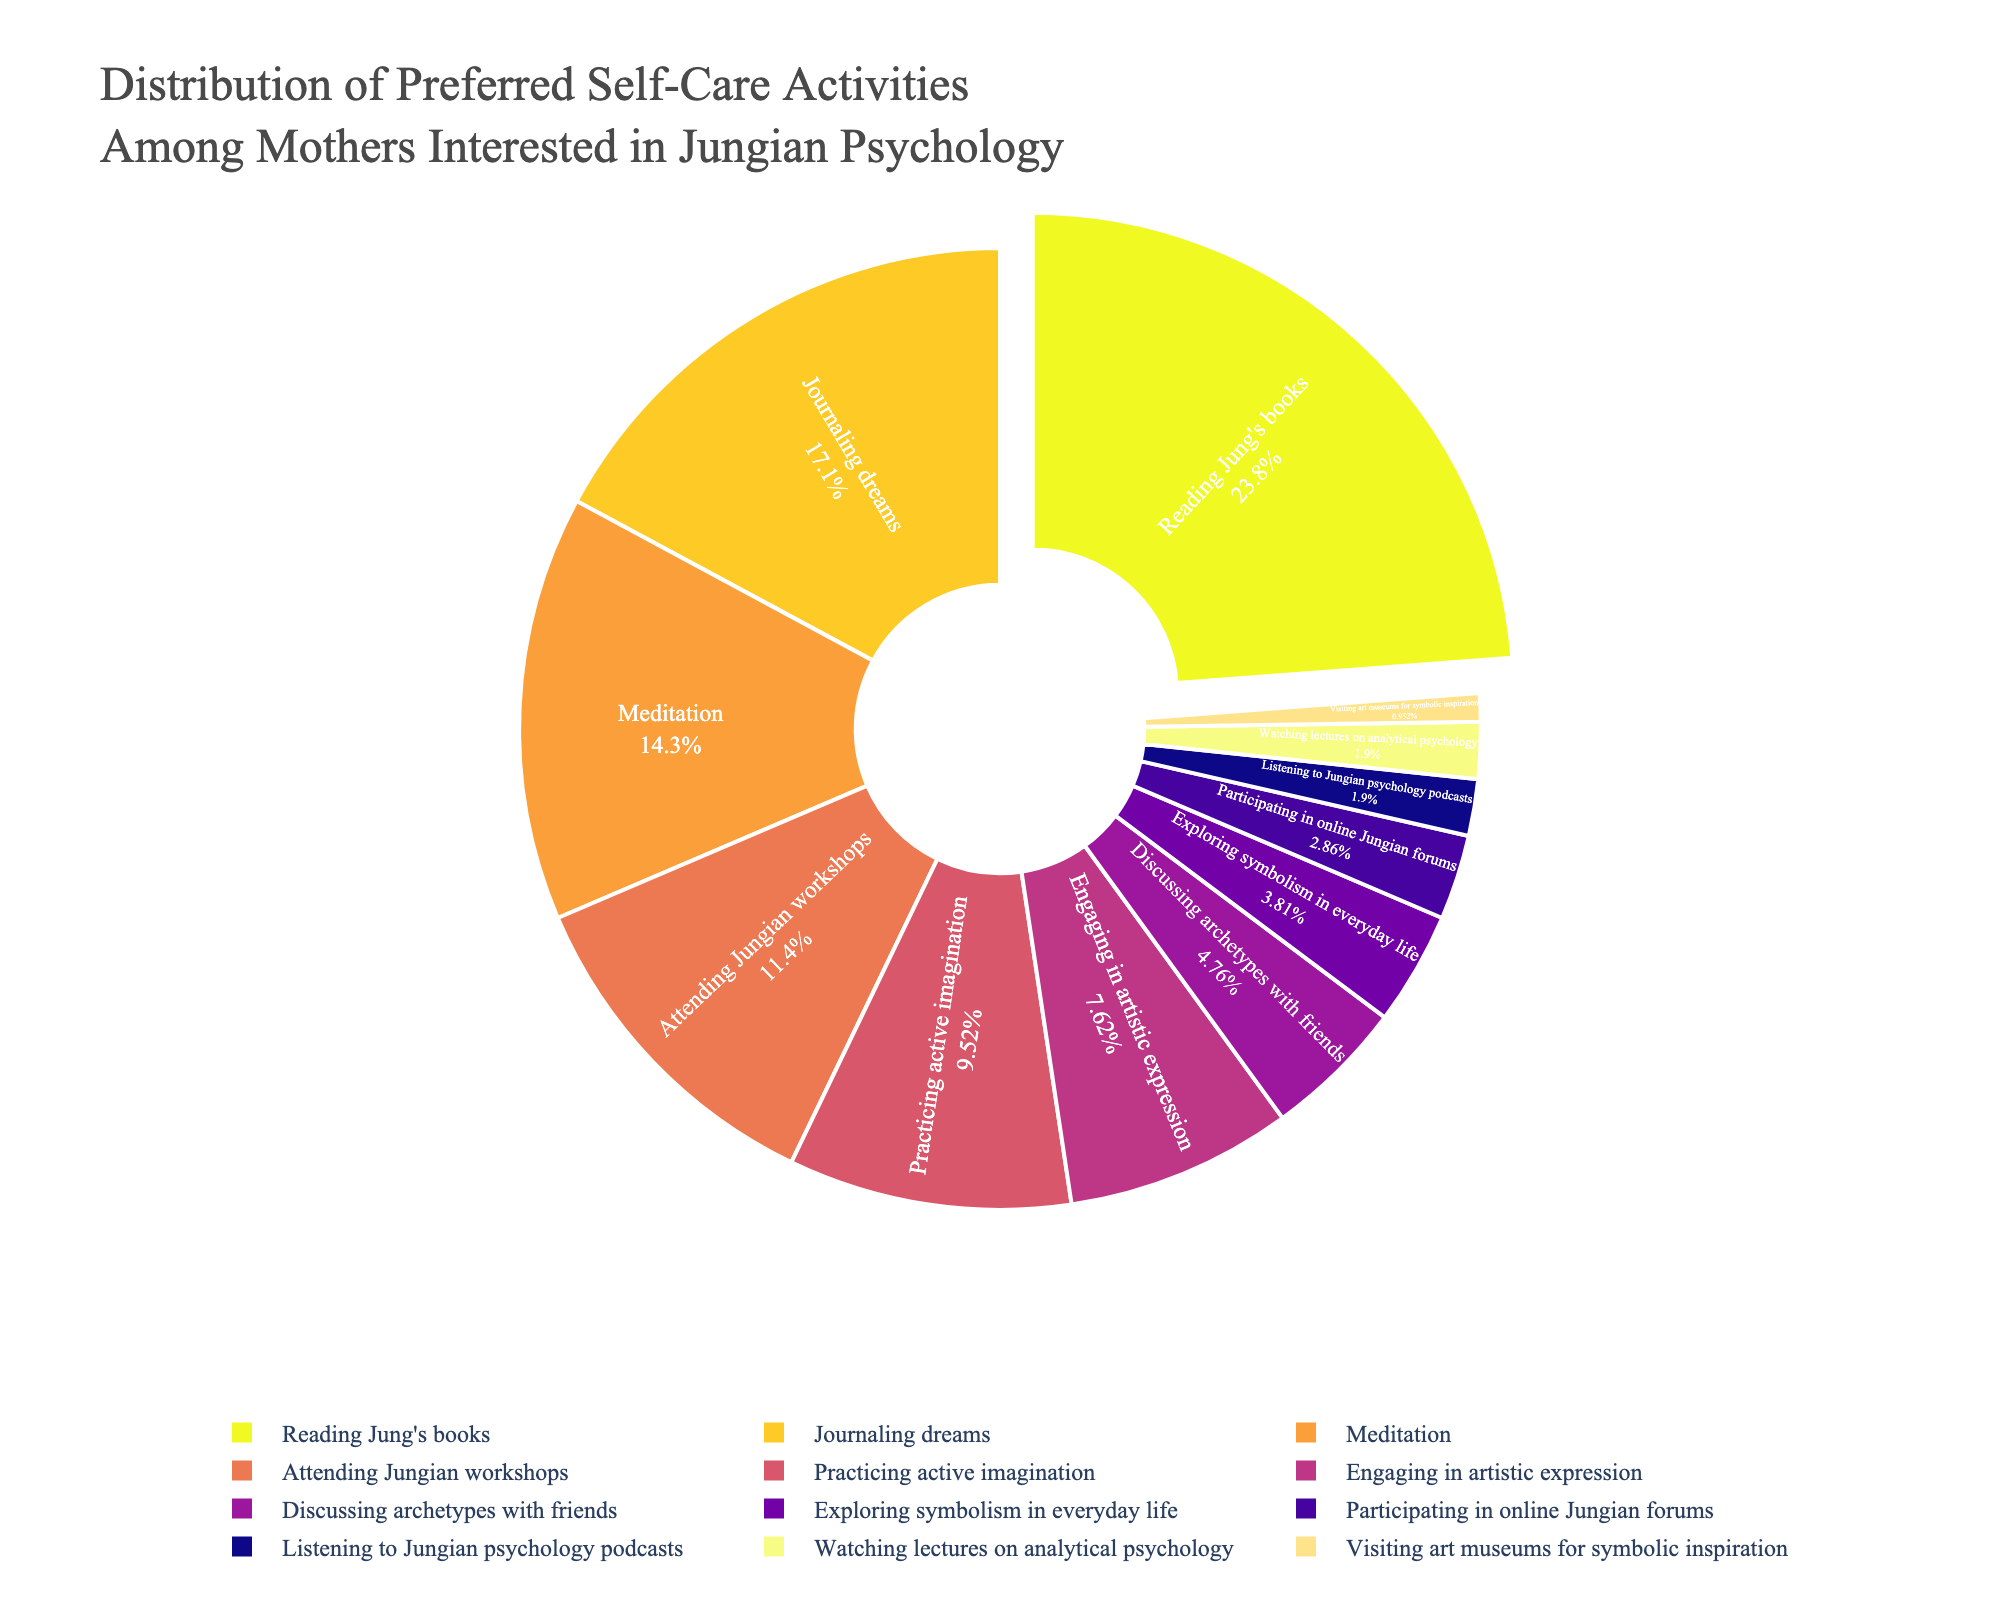Which activity has the highest percentage? The activity with the highest percentage corresponds to the largest slice in the pie chart. Observing the chart, the largest slice is for "Reading Jung's books".
Answer: Reading Jung's books What is the total percentage of activities related to writing (Reading Jung's books, Journaling dreams)? Sum the percentages of "Reading Jung's books" (25%) and "Journaling dreams" (18%) together.
Answer: 43% How many activities have a percentage lower than 10%? Count the slices in the pie chart that have percentages lower than 10%. "Practicing active imagination", "Engaging in artistic expression", "Discussing archetypes with friends", "Exploring symbolism in everyday life", "Participating in online Jungian forums", "Listening to Jungian psychology podcasts", "Watching lectures on analytical psychology", and "Visiting art museums for symbolic inspiration" all fall below 10%.
Answer: 8 Which activity has the smallest percentage? The activity with the smallest slice in the pie chart has the smallest percentage. The smallest slice corresponds to "Visiting art museums for symbolic inspiration".
Answer: Visiting art museums for symbolic inspiration What is the difference in percentage between the highest and lowest activities? Calculate the percentage difference between "Reading Jung's books" (25%) and "Visiting art museums for symbolic inspiration" (1%). Subtract 1% from 25%.
Answer: 24% Which categories combined make up exactly half of the total percentage? Select activities until their summed percentages total 50%. "Reading Jung's books" (25%) and "Journaling dreams" (18%) add up to 43%, then adding "Meditation" (15%) makes it 58%, which is too much. Removing "Meditation" and instead adding "Attending Jungian workshops" (12%) results in exactly 50%.
Answer: Reading Jung's books, Journaling dreams, Attending Jungian workshops Compare the percentage of "Engaging in artistic expression" to "Discussing archetypes with friends". Which one is higher? Observe the pie chart slices corresponding to both activities and compare their sizes. "Engaging in artistic expression" has a percentage of 8%, while "Discussing archetypes with friends" has 5%.
Answer: Engaging in artistic expression What is the total percentage of activities related to social interaction (Attending Jungian workshops, Discussing archetypes with friends, Participating in online Jungian forums)? Sum the percentages of "Attending Jungian workshops" (12%), "Discussing archetypes with friends" (5%), and "Participating in online Jungian forums" (3%).
Answer: 20% 